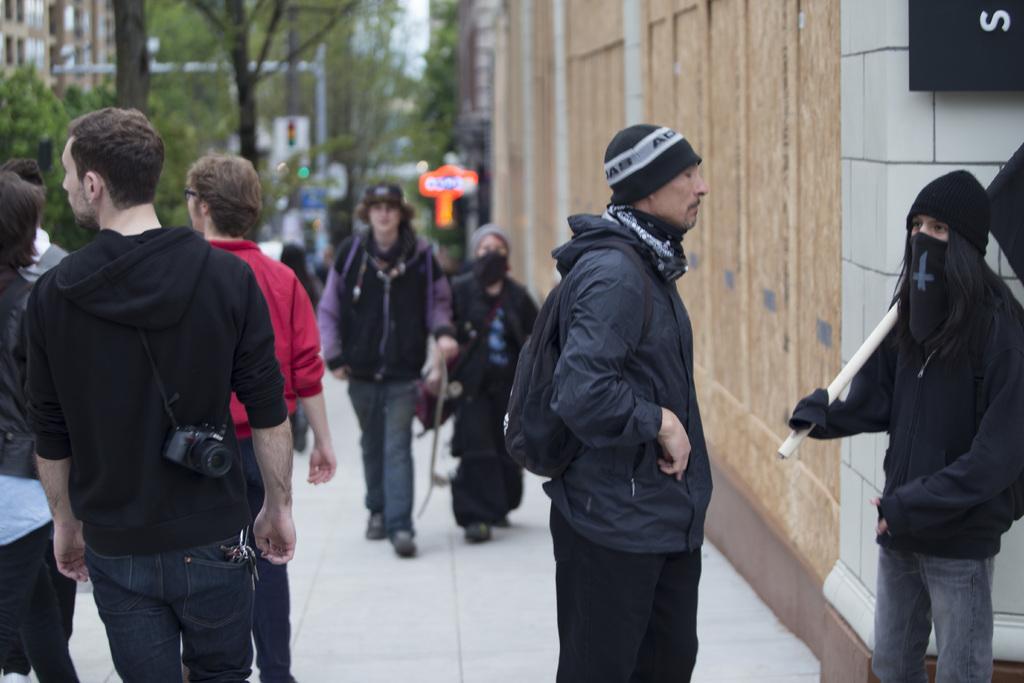Can you describe this image briefly? In this image I can see number of people are standing and I can see most of them are wearing jackets. On the right side of this image I can see two persons are wearing caps and one of them is carrying a bag. On the top right corner of this image I can see a black colour thing and on it I can see something is written. In the background I can see number of trees, few poles, few buildings and I can see this image is little bit blurry in the background. On the left side of this image I can see a person is carrying a camera. 